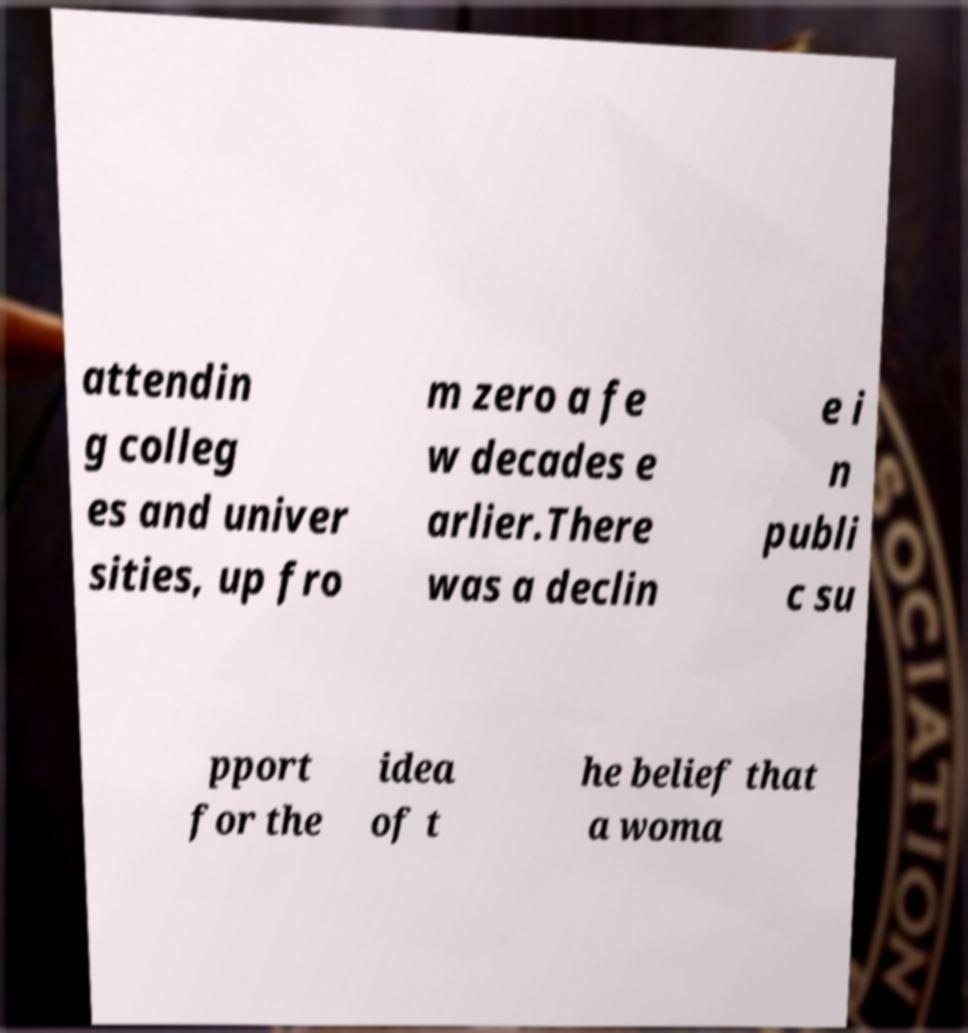Can you accurately transcribe the text from the provided image for me? attendin g colleg es and univer sities, up fro m zero a fe w decades e arlier.There was a declin e i n publi c su pport for the idea of t he belief that a woma 